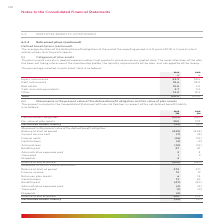According to Woolworths Limited's financial document, What factors are taken into consideration when setting the asset allocation of the plan? the membership profile, the liquidity requirements of the plan, and risk appetite of the Group.. The document states: "ation of the plan has been set taking into account the membership profile, the liquidity requirements of the plan, and risk appetite of the Group...." Also, What is the average duration of the defined benefit obligation at the end of the reporting period? According to the financial document, 6.8 years. The relevant text states: "obligation at the end of the reporting period is 6.8 years (2018: 6.3 years) which relates wholly to active participants...." Also, What does the plan invests in? pooled superannuation trust products where prices are quoted daily.. The document states: "gories of plan assets The plan invests entirely in pooled superannuation trust products where prices are quoted daily. The asset allocation of the pla..." Also, can you calculate: What is the difference in equity instruments between 2018 and 2019? Based on the calculation: 58.5% - 53.9% , the result is 4.6 (percentage). This is based on the information: "Equity instruments 53.9 58.5 Debt instruments 18.6 22.5 Real estate 10.8 3.5 Cash and cash equivalents 3.7 3.0 Other 13.0 12.5 T Equity instruments 53.9 58.5 Debt instruments 18.6 22.5 Real estate 10...." The key data points involved are: 53.9, 58.5. Also, can you calculate: What is the average percentage constitution of real estate for 2018 and 2019? To answer this question, I need to perform calculations using the financial data. The calculation is: (10.8% + 3.5%)/2 , which equals 7.15 (percentage). This is based on the information: "58.5 Debt instruments 18.6 22.5 Real estate 10.8 3.5 Cash and cash equivalents 3.7 3.0 Other 13.0 12.5 Total 100.0 100.0 53.9 58.5 Debt instruments 18.6 22.5 Real estate 10.8 3.5 Cash and cash equival..." The key data points involved are: 10.8, 2, 3.5. Also, can you calculate: What is the difference in debt instruments between 2018 and 2019? Based on the calculation: 22.5% - 18.6% , the result is 3.9 (percentage). This is based on the information: "Equity instruments 53.9 58.5 Debt instruments 18.6 22.5 Real estate 10.8 3.5 Cash and cash equivalents 3.7 3.0 Other 13.0 12.5 Total 100.0 100.0 quity instruments 53.9 58.5 Debt instruments 18.6 22.5 ..." The key data points involved are: 18.6, 22.5. 